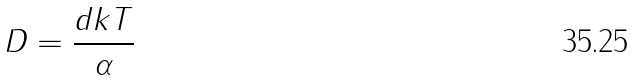Convert formula to latex. <formula><loc_0><loc_0><loc_500><loc_500>D = \frac { d k T } { \alpha }</formula> 